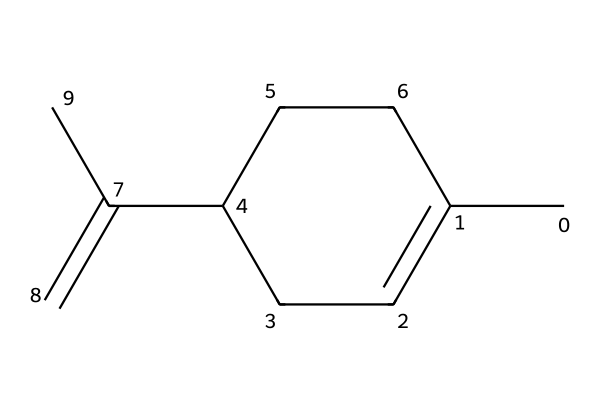What is the molecular formula of limonene? By analyzing the provided SMILES representation, we can count the number of carbon and hydrogen atoms: there are ten carbon atoms and sixteen hydrogen atoms. Thus, the molecular formula can be deduced as C10H16.
Answer: C10H16 How many double bonds are present in limonene? A closer look at the structure (from the SMILES) reveals one double bond in the carbon chain (the C=C present), indicating that limonene has one carbon-carbon double bond.
Answer: 1 What type of compound is limonene classified as? Limonene has a specific structure characterized by its cyclic and acyclic features and its functionality as a terpene, which are hydrocarbons produced by many plants. Therefore, it is classified as a terpene.
Answer: terpene What is the maximum number of hydrogen atoms limonene could theoretically have? To find the maximum hydrogen count for a non-cyclic alkane based on the number of carbon atoms, we can use the formula CnH2n+2, where n is the number of carbons. With 10 carbons, the maximum number is H22. Since limonene is a terpene, its structure is unable to achieve this due to the presence of double bonds. However, the theoretical maximum is still derived from the perfect alkane structure.
Answer: 22 Does limonene have any functional groups? Looking at the structure derived from the SMILES, there are no hydroxyl (-OH), carboxyl (-COOH), or other specific functional groups typically found in organic compounds. Thus, limonene does not contain any functional groups.
Answer: none 